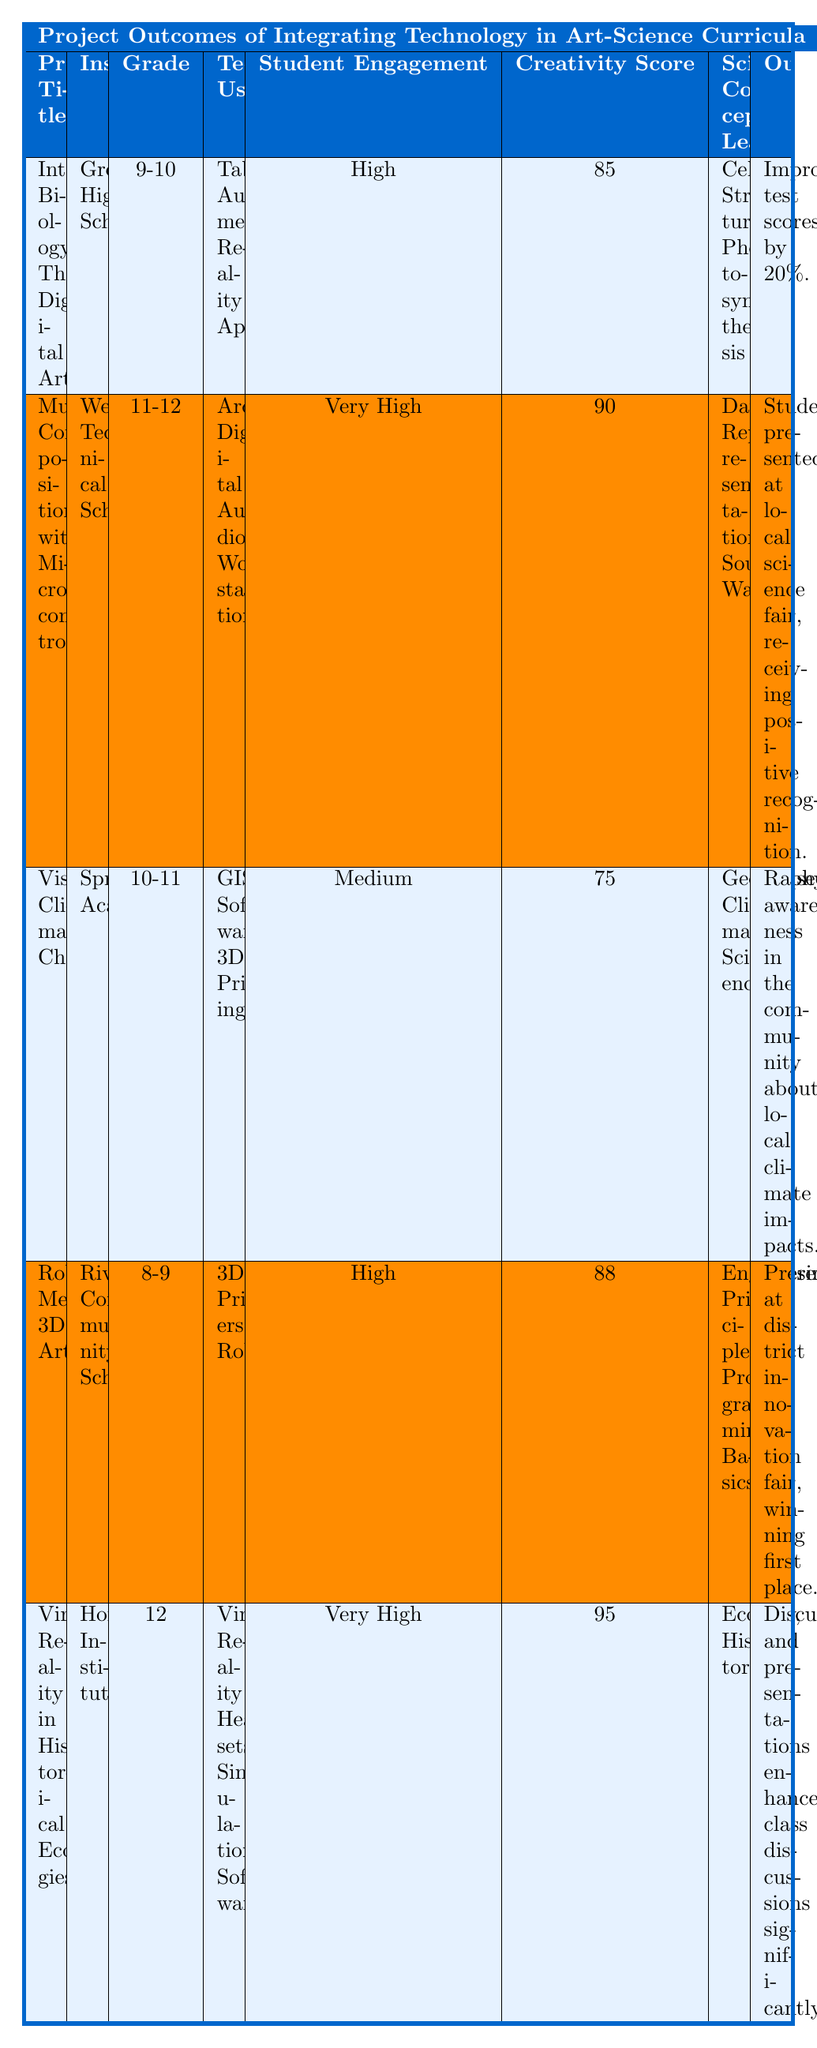What is the highest Creativity Score among the projects? The highest Creativity Score listed in the table is 95, which corresponds to the project "Virtual Reality in Historical Ecologies."
Answer: 95 Which project raised community awareness about climate impacts? The project titled "Visualizing Climate Change" raised awareness in the community about local climate impacts, as stated in the outcome.
Answer: Visualizing Climate Change How many weeks did the "Music Composition with Microcontrollers" project last? The table shows that the "Music Composition with Microcontrollers" project had a duration of 8 weeks.
Answer: 8 What is the overall average Creativity Score for all the projects? To calculate the average Creativity Score: (85 + 90 + 75 + 88 + 95) = 433. There are 5 projects, so the average is 433/5 = 86.6.
Answer: 86.6 Did all projects have high student engagement levels? No, the "Visualizing Climate Change" project had a medium level of student engagement, while the other projects listed as high or very high engagement.
Answer: No Which project had the longest duration, and how long was it? The project "Virtual Reality in Historical Ecologies" had the longest duration of 10 weeks, as seen in the table.
Answer: Virtual Reality in Historical Ecologies, 10 weeks Are there any projects that incorporated augmented reality tools? Yes, the project "Interactive Biology Through Digital Art" incorporated augmented reality tools as part of its technology used.
Answer: Yes What is the difference in Creativity Score between the highest and lowest projects? The highest Creativity Score is 95 (from "Virtual Reality in Historical Ecologies"), and the lowest is 75 (from "Visualizing Climate Change"). The difference is 95 - 75 = 20.
Answer: 20 How many unique technology types were used across all projects? The unique technology types used are Tablets, Augmented Reality App, Arduino, Digital Audio Workstation, GIS Software, 3D Printing, 3D Printers, Robots, Virtual Reality Headsets, and Simulation Software. This totals to 10 unique types.
Answer: 10 Which project focused on art-science integration through data representation? The project "Music Composition with Microcontrollers" focused on integrating art and science through data representation, using data from environmental sensors to compose music.
Answer: Music Composition with Microcontrollers 